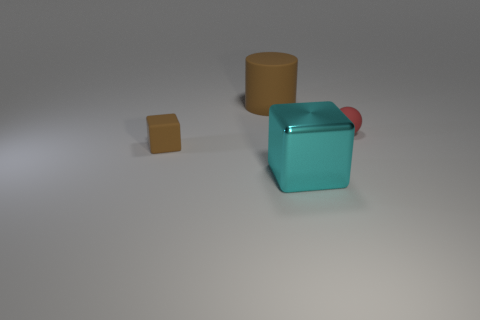There is a tiny cube that is the same color as the big rubber cylinder; what material is it?
Offer a terse response. Rubber. How many objects are either big cyan things that are in front of the tiny brown object or balls?
Keep it short and to the point. 2. Are there any large yellow cylinders?
Your answer should be very brief. No. What shape is the thing that is both in front of the large matte thing and on the left side of the large cyan thing?
Provide a short and direct response. Cube. There is a block behind the large cyan object; how big is it?
Provide a short and direct response. Small. There is a tiny matte thing that is to the left of the sphere; is its color the same as the big cylinder?
Offer a terse response. Yes. How many other large brown things are the same shape as the big matte thing?
Your answer should be compact. 0. How many objects are things on the left side of the matte cylinder or blocks behind the cyan metal object?
Offer a very short reply. 1. How many cyan things are large rubber cylinders or small spheres?
Offer a very short reply. 0. There is a thing that is on the right side of the rubber cylinder and left of the tiny ball; what material is it made of?
Make the answer very short. Metal. 